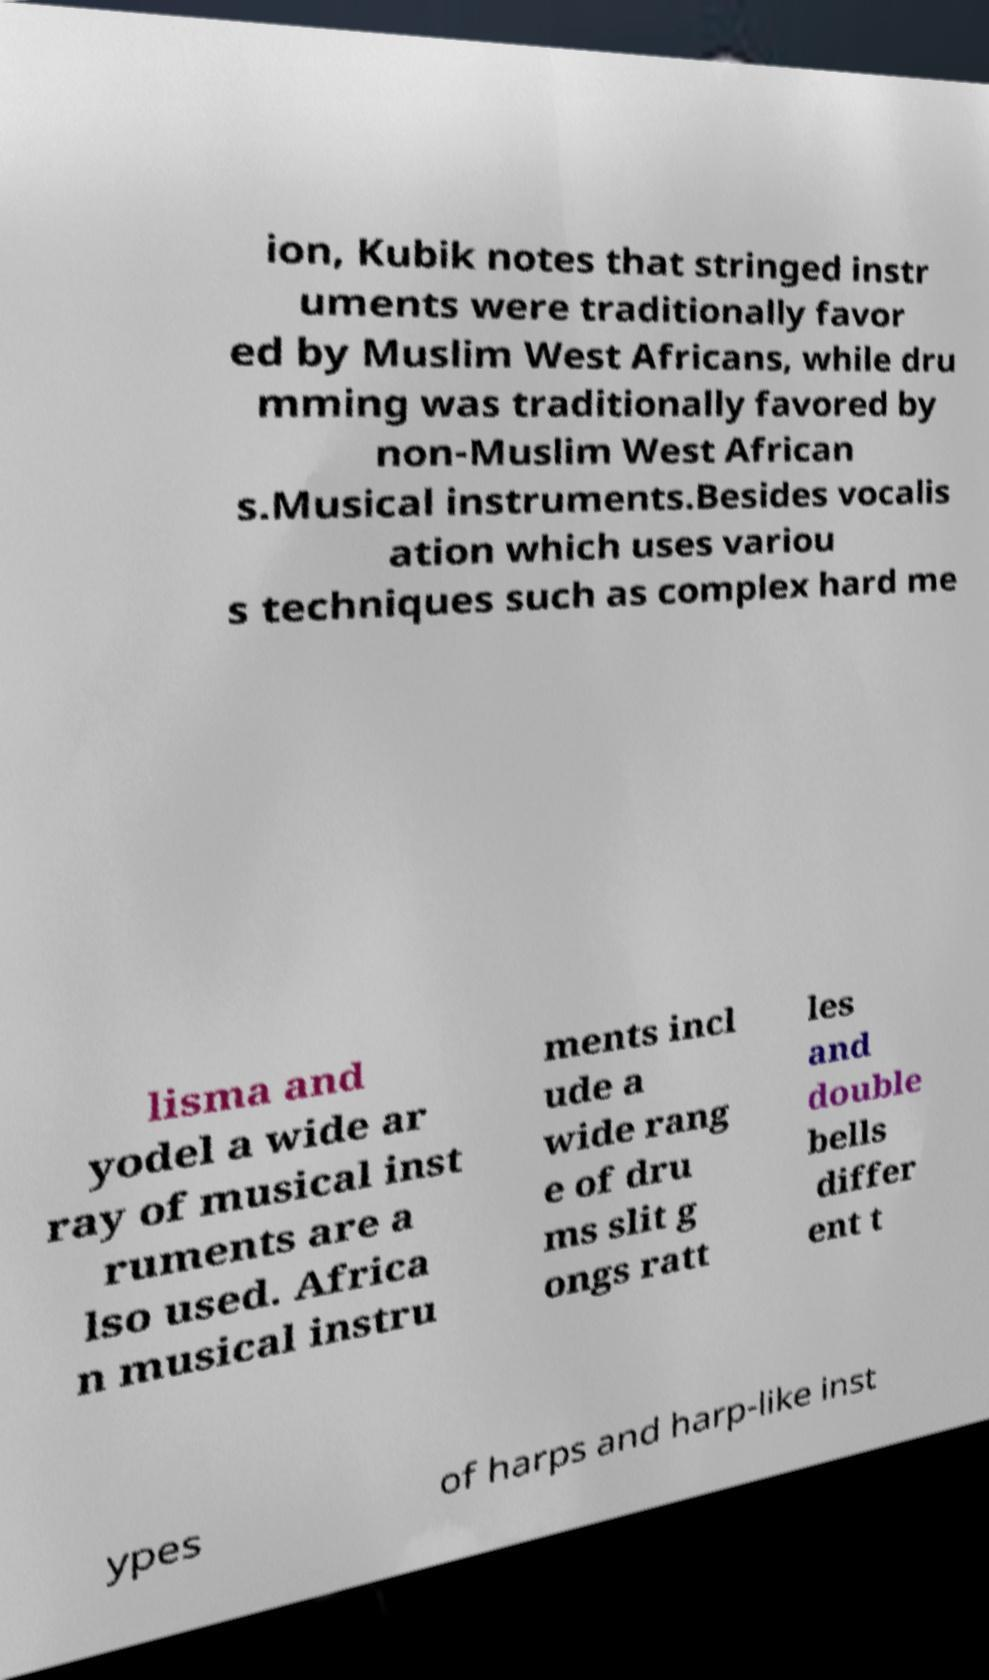What messages or text are displayed in this image? I need them in a readable, typed format. ion, Kubik notes that stringed instr uments were traditionally favor ed by Muslim West Africans, while dru mming was traditionally favored by non-Muslim West African s.Musical instruments.Besides vocalis ation which uses variou s techniques such as complex hard me lisma and yodel a wide ar ray of musical inst ruments are a lso used. Africa n musical instru ments incl ude a wide rang e of dru ms slit g ongs ratt les and double bells differ ent t ypes of harps and harp-like inst 